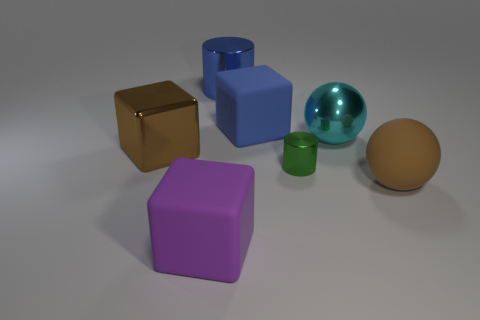Add 1 brown balls. How many objects exist? 8 Subtract all blocks. How many objects are left? 4 Add 5 big blue rubber blocks. How many big blue rubber blocks exist? 6 Subtract 0 cyan cubes. How many objects are left? 7 Subtract all shiny cylinders. Subtract all rubber balls. How many objects are left? 4 Add 7 brown spheres. How many brown spheres are left? 8 